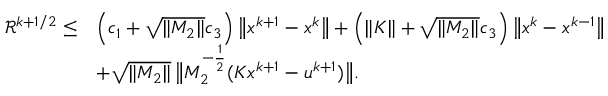Convert formula to latex. <formula><loc_0><loc_0><loc_500><loc_500>\begin{array} { r l } { \mathcal { R } ^ { k + 1 / 2 } \leq } & { \left ( c _ { 1 } + \sqrt { \| M _ { 2 } \| } c _ { 3 } \right ) \left \| x ^ { k + 1 } - x ^ { k } \right \| + \left ( \| K \| + \sqrt { \| M _ { 2 } \| } c _ { 3 } \right ) \left \| x ^ { k } - x ^ { k - 1 } \right \| } & { + \sqrt { \| M _ { 2 } \| } \, \left \| M _ { 2 } ^ { - \frac { 1 } { 2 } } ( K x ^ { k + 1 } - u ^ { k + 1 } ) \right \| . } \end{array}</formula> 